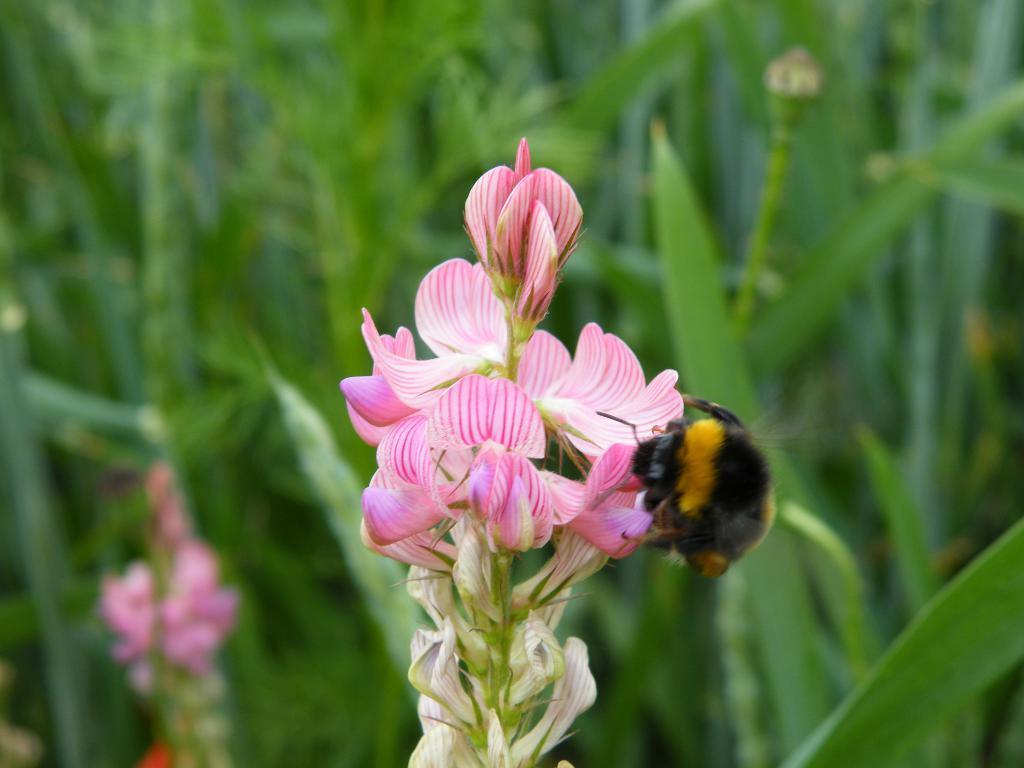In one or two sentences, can you explain what this image depicts? This image consists of flowers in pink color. On which there is a honey bee. In the background, there are many plants. And the background is blurred. 